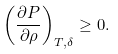<formula> <loc_0><loc_0><loc_500><loc_500>\left ( \frac { \partial P } { \partial \rho } \right ) _ { T , \delta } \geq 0 .</formula> 